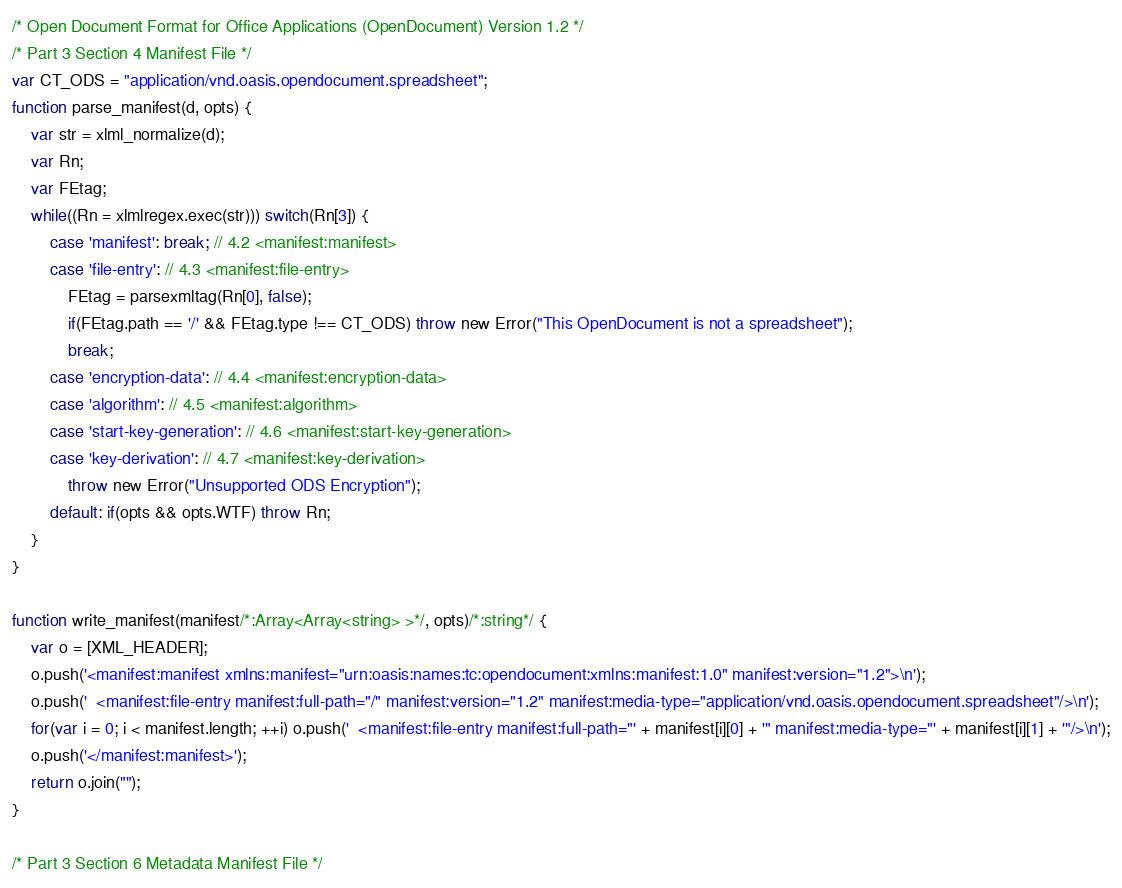<code> <loc_0><loc_0><loc_500><loc_500><_JavaScript_>/* Open Document Format for Office Applications (OpenDocument) Version 1.2 */
/* Part 3 Section 4 Manifest File */
var CT_ODS = "application/vnd.oasis.opendocument.spreadsheet";
function parse_manifest(d, opts) {
	var str = xlml_normalize(d);
	var Rn;
	var FEtag;
	while((Rn = xlmlregex.exec(str))) switch(Rn[3]) {
		case 'manifest': break; // 4.2 <manifest:manifest>
		case 'file-entry': // 4.3 <manifest:file-entry>
			FEtag = parsexmltag(Rn[0], false);
			if(FEtag.path == '/' && FEtag.type !== CT_ODS) throw new Error("This OpenDocument is not a spreadsheet");
			break;
		case 'encryption-data': // 4.4 <manifest:encryption-data>
		case 'algorithm': // 4.5 <manifest:algorithm>
		case 'start-key-generation': // 4.6 <manifest:start-key-generation>
		case 'key-derivation': // 4.7 <manifest:key-derivation>
			throw new Error("Unsupported ODS Encryption");
		default: if(opts && opts.WTF) throw Rn;
	}
}

function write_manifest(manifest/*:Array<Array<string> >*/, opts)/*:string*/ {
	var o = [XML_HEADER];
	o.push('<manifest:manifest xmlns:manifest="urn:oasis:names:tc:opendocument:xmlns:manifest:1.0" manifest:version="1.2">\n');
	o.push('  <manifest:file-entry manifest:full-path="/" manifest:version="1.2" manifest:media-type="application/vnd.oasis.opendocument.spreadsheet"/>\n');
	for(var i = 0; i < manifest.length; ++i) o.push('  <manifest:file-entry manifest:full-path="' + manifest[i][0] + '" manifest:media-type="' + manifest[i][1] + '"/>\n');
	o.push('</manifest:manifest>');
	return o.join("");
}

/* Part 3 Section 6 Metadata Manifest File */</code> 